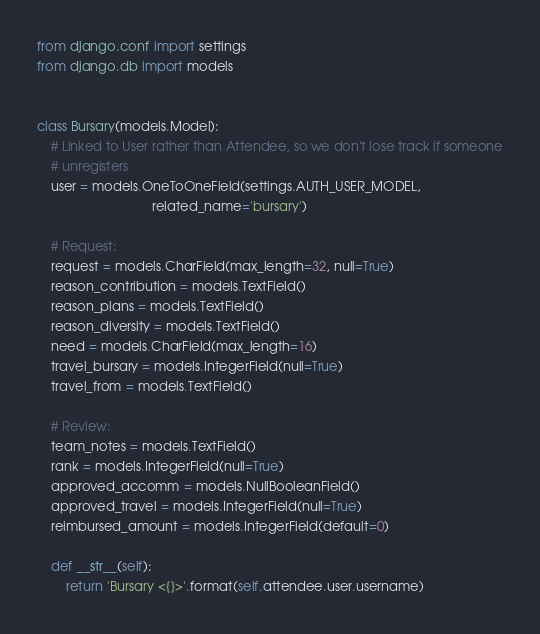Convert code to text. <code><loc_0><loc_0><loc_500><loc_500><_Python_>from django.conf import settings
from django.db import models


class Bursary(models.Model):
    # Linked to User rather than Attendee, so we don't lose track if someone
    # unregisters
    user = models.OneToOneField(settings.AUTH_USER_MODEL,
                                related_name='bursary')

    # Request:
    request = models.CharField(max_length=32, null=True)
    reason_contribution = models.TextField()
    reason_plans = models.TextField()
    reason_diversity = models.TextField()
    need = models.CharField(max_length=16)
    travel_bursary = models.IntegerField(null=True)
    travel_from = models.TextField()

    # Review:
    team_notes = models.TextField()
    rank = models.IntegerField(null=True)
    approved_accomm = models.NullBooleanField()
    approved_travel = models.IntegerField(null=True)
    reimbursed_amount = models.IntegerField(default=0)

    def __str__(self):
        return 'Bursary <{}>'.format(self.attendee.user.username)
</code> 